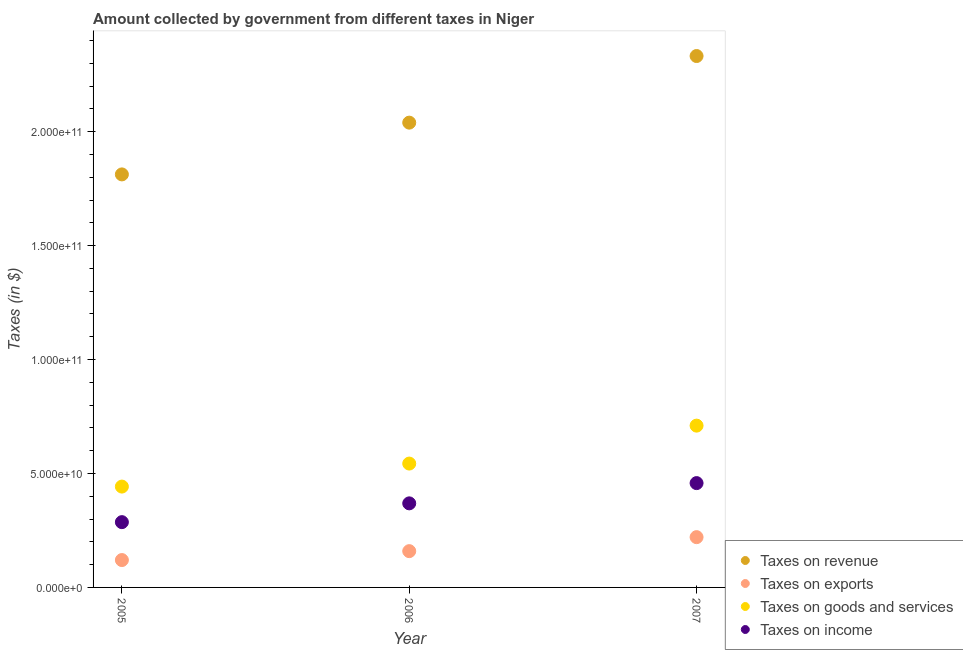How many different coloured dotlines are there?
Provide a short and direct response. 4. What is the amount collected as tax on revenue in 2007?
Provide a short and direct response. 2.33e+11. Across all years, what is the maximum amount collected as tax on exports?
Provide a succinct answer. 2.21e+1. Across all years, what is the minimum amount collected as tax on exports?
Your response must be concise. 1.20e+1. In which year was the amount collected as tax on goods maximum?
Give a very brief answer. 2007. In which year was the amount collected as tax on income minimum?
Provide a succinct answer. 2005. What is the total amount collected as tax on revenue in the graph?
Your answer should be compact. 6.18e+11. What is the difference between the amount collected as tax on exports in 2005 and that in 2006?
Your answer should be compact. -3.91e+09. What is the difference between the amount collected as tax on revenue in 2006 and the amount collected as tax on goods in 2005?
Offer a terse response. 1.60e+11. What is the average amount collected as tax on goods per year?
Ensure brevity in your answer.  5.65e+1. In the year 2005, what is the difference between the amount collected as tax on income and amount collected as tax on exports?
Offer a very short reply. 1.66e+1. In how many years, is the amount collected as tax on income greater than 90000000000 $?
Keep it short and to the point. 0. What is the ratio of the amount collected as tax on goods in 2005 to that in 2006?
Offer a very short reply. 0.81. Is the amount collected as tax on revenue in 2006 less than that in 2007?
Offer a terse response. Yes. What is the difference between the highest and the second highest amount collected as tax on goods?
Your answer should be very brief. 1.66e+1. What is the difference between the highest and the lowest amount collected as tax on revenue?
Make the answer very short. 5.19e+1. Is the sum of the amount collected as tax on income in 2005 and 2006 greater than the maximum amount collected as tax on revenue across all years?
Ensure brevity in your answer.  No. Is it the case that in every year, the sum of the amount collected as tax on exports and amount collected as tax on goods is greater than the sum of amount collected as tax on income and amount collected as tax on revenue?
Offer a very short reply. No. Is the amount collected as tax on revenue strictly less than the amount collected as tax on goods over the years?
Give a very brief answer. No. How many years are there in the graph?
Provide a succinct answer. 3. What is the difference between two consecutive major ticks on the Y-axis?
Offer a very short reply. 5.00e+1. Are the values on the major ticks of Y-axis written in scientific E-notation?
Ensure brevity in your answer.  Yes. How many legend labels are there?
Ensure brevity in your answer.  4. How are the legend labels stacked?
Give a very brief answer. Vertical. What is the title of the graph?
Offer a very short reply. Amount collected by government from different taxes in Niger. Does "Pre-primary schools" appear as one of the legend labels in the graph?
Your answer should be compact. No. What is the label or title of the X-axis?
Keep it short and to the point. Year. What is the label or title of the Y-axis?
Keep it short and to the point. Taxes (in $). What is the Taxes (in $) in Taxes on revenue in 2005?
Offer a terse response. 1.81e+11. What is the Taxes (in $) in Taxes on exports in 2005?
Keep it short and to the point. 1.20e+1. What is the Taxes (in $) in Taxes on goods and services in 2005?
Keep it short and to the point. 4.43e+1. What is the Taxes (in $) of Taxes on income in 2005?
Provide a succinct answer. 2.86e+1. What is the Taxes (in $) in Taxes on revenue in 2006?
Give a very brief answer. 2.04e+11. What is the Taxes (in $) of Taxes on exports in 2006?
Keep it short and to the point. 1.59e+1. What is the Taxes (in $) in Taxes on goods and services in 2006?
Provide a short and direct response. 5.43e+1. What is the Taxes (in $) in Taxes on income in 2006?
Offer a very short reply. 3.69e+1. What is the Taxes (in $) in Taxes on revenue in 2007?
Offer a terse response. 2.33e+11. What is the Taxes (in $) in Taxes on exports in 2007?
Provide a succinct answer. 2.21e+1. What is the Taxes (in $) of Taxes on goods and services in 2007?
Your answer should be compact. 7.10e+1. What is the Taxes (in $) in Taxes on income in 2007?
Your response must be concise. 4.58e+1. Across all years, what is the maximum Taxes (in $) of Taxes on revenue?
Keep it short and to the point. 2.33e+11. Across all years, what is the maximum Taxes (in $) in Taxes on exports?
Offer a terse response. 2.21e+1. Across all years, what is the maximum Taxes (in $) of Taxes on goods and services?
Offer a terse response. 7.10e+1. Across all years, what is the maximum Taxes (in $) of Taxes on income?
Your answer should be very brief. 4.58e+1. Across all years, what is the minimum Taxes (in $) in Taxes on revenue?
Provide a succinct answer. 1.81e+11. Across all years, what is the minimum Taxes (in $) in Taxes on exports?
Provide a succinct answer. 1.20e+1. Across all years, what is the minimum Taxes (in $) in Taxes on goods and services?
Offer a terse response. 4.43e+1. Across all years, what is the minimum Taxes (in $) of Taxes on income?
Provide a succinct answer. 2.86e+1. What is the total Taxes (in $) of Taxes on revenue in the graph?
Keep it short and to the point. 6.18e+11. What is the total Taxes (in $) in Taxes on exports in the graph?
Your answer should be compact. 5.00e+1. What is the total Taxes (in $) of Taxes on goods and services in the graph?
Your answer should be very brief. 1.70e+11. What is the total Taxes (in $) in Taxes on income in the graph?
Provide a succinct answer. 1.11e+11. What is the difference between the Taxes (in $) of Taxes on revenue in 2005 and that in 2006?
Provide a short and direct response. -2.27e+1. What is the difference between the Taxes (in $) in Taxes on exports in 2005 and that in 2006?
Ensure brevity in your answer.  -3.91e+09. What is the difference between the Taxes (in $) of Taxes on goods and services in 2005 and that in 2006?
Make the answer very short. -1.01e+1. What is the difference between the Taxes (in $) in Taxes on income in 2005 and that in 2006?
Offer a very short reply. -8.25e+09. What is the difference between the Taxes (in $) in Taxes on revenue in 2005 and that in 2007?
Ensure brevity in your answer.  -5.19e+1. What is the difference between the Taxes (in $) in Taxes on exports in 2005 and that in 2007?
Provide a short and direct response. -1.01e+1. What is the difference between the Taxes (in $) of Taxes on goods and services in 2005 and that in 2007?
Keep it short and to the point. -2.67e+1. What is the difference between the Taxes (in $) in Taxes on income in 2005 and that in 2007?
Ensure brevity in your answer.  -1.71e+1. What is the difference between the Taxes (in $) in Taxes on revenue in 2006 and that in 2007?
Give a very brief answer. -2.92e+1. What is the difference between the Taxes (in $) in Taxes on exports in 2006 and that in 2007?
Ensure brevity in your answer.  -6.14e+09. What is the difference between the Taxes (in $) of Taxes on goods and services in 2006 and that in 2007?
Give a very brief answer. -1.66e+1. What is the difference between the Taxes (in $) of Taxes on income in 2006 and that in 2007?
Make the answer very short. -8.88e+09. What is the difference between the Taxes (in $) in Taxes on revenue in 2005 and the Taxes (in $) in Taxes on exports in 2006?
Give a very brief answer. 1.65e+11. What is the difference between the Taxes (in $) of Taxes on revenue in 2005 and the Taxes (in $) of Taxes on goods and services in 2006?
Offer a very short reply. 1.27e+11. What is the difference between the Taxes (in $) in Taxes on revenue in 2005 and the Taxes (in $) in Taxes on income in 2006?
Keep it short and to the point. 1.44e+11. What is the difference between the Taxes (in $) in Taxes on exports in 2005 and the Taxes (in $) in Taxes on goods and services in 2006?
Your answer should be compact. -4.23e+1. What is the difference between the Taxes (in $) in Taxes on exports in 2005 and the Taxes (in $) in Taxes on income in 2006?
Offer a terse response. -2.49e+1. What is the difference between the Taxes (in $) in Taxes on goods and services in 2005 and the Taxes (in $) in Taxes on income in 2006?
Offer a terse response. 7.36e+09. What is the difference between the Taxes (in $) of Taxes on revenue in 2005 and the Taxes (in $) of Taxes on exports in 2007?
Offer a terse response. 1.59e+11. What is the difference between the Taxes (in $) of Taxes on revenue in 2005 and the Taxes (in $) of Taxes on goods and services in 2007?
Provide a short and direct response. 1.10e+11. What is the difference between the Taxes (in $) of Taxes on revenue in 2005 and the Taxes (in $) of Taxes on income in 2007?
Ensure brevity in your answer.  1.35e+11. What is the difference between the Taxes (in $) in Taxes on exports in 2005 and the Taxes (in $) in Taxes on goods and services in 2007?
Offer a very short reply. -5.90e+1. What is the difference between the Taxes (in $) of Taxes on exports in 2005 and the Taxes (in $) of Taxes on income in 2007?
Offer a very short reply. -3.38e+1. What is the difference between the Taxes (in $) in Taxes on goods and services in 2005 and the Taxes (in $) in Taxes on income in 2007?
Your response must be concise. -1.53e+09. What is the difference between the Taxes (in $) of Taxes on revenue in 2006 and the Taxes (in $) of Taxes on exports in 2007?
Your response must be concise. 1.82e+11. What is the difference between the Taxes (in $) of Taxes on revenue in 2006 and the Taxes (in $) of Taxes on goods and services in 2007?
Provide a short and direct response. 1.33e+11. What is the difference between the Taxes (in $) of Taxes on revenue in 2006 and the Taxes (in $) of Taxes on income in 2007?
Your answer should be compact. 1.58e+11. What is the difference between the Taxes (in $) in Taxes on exports in 2006 and the Taxes (in $) in Taxes on goods and services in 2007?
Your answer should be compact. -5.51e+1. What is the difference between the Taxes (in $) of Taxes on exports in 2006 and the Taxes (in $) of Taxes on income in 2007?
Offer a terse response. -2.99e+1. What is the difference between the Taxes (in $) of Taxes on goods and services in 2006 and the Taxes (in $) of Taxes on income in 2007?
Make the answer very short. 8.57e+09. What is the average Taxes (in $) in Taxes on revenue per year?
Provide a short and direct response. 2.06e+11. What is the average Taxes (in $) of Taxes on exports per year?
Your answer should be very brief. 1.67e+1. What is the average Taxes (in $) in Taxes on goods and services per year?
Provide a succinct answer. 5.65e+1. What is the average Taxes (in $) of Taxes on income per year?
Make the answer very short. 3.71e+1. In the year 2005, what is the difference between the Taxes (in $) in Taxes on revenue and Taxes (in $) in Taxes on exports?
Provide a short and direct response. 1.69e+11. In the year 2005, what is the difference between the Taxes (in $) in Taxes on revenue and Taxes (in $) in Taxes on goods and services?
Your answer should be very brief. 1.37e+11. In the year 2005, what is the difference between the Taxes (in $) in Taxes on revenue and Taxes (in $) in Taxes on income?
Your answer should be compact. 1.53e+11. In the year 2005, what is the difference between the Taxes (in $) of Taxes on exports and Taxes (in $) of Taxes on goods and services?
Ensure brevity in your answer.  -3.22e+1. In the year 2005, what is the difference between the Taxes (in $) of Taxes on exports and Taxes (in $) of Taxes on income?
Keep it short and to the point. -1.66e+1. In the year 2005, what is the difference between the Taxes (in $) in Taxes on goods and services and Taxes (in $) in Taxes on income?
Make the answer very short. 1.56e+1. In the year 2006, what is the difference between the Taxes (in $) in Taxes on revenue and Taxes (in $) in Taxes on exports?
Offer a very short reply. 1.88e+11. In the year 2006, what is the difference between the Taxes (in $) of Taxes on revenue and Taxes (in $) of Taxes on goods and services?
Offer a terse response. 1.50e+11. In the year 2006, what is the difference between the Taxes (in $) in Taxes on revenue and Taxes (in $) in Taxes on income?
Your answer should be very brief. 1.67e+11. In the year 2006, what is the difference between the Taxes (in $) in Taxes on exports and Taxes (in $) in Taxes on goods and services?
Give a very brief answer. -3.84e+1. In the year 2006, what is the difference between the Taxes (in $) of Taxes on exports and Taxes (in $) of Taxes on income?
Provide a succinct answer. -2.10e+1. In the year 2006, what is the difference between the Taxes (in $) in Taxes on goods and services and Taxes (in $) in Taxes on income?
Ensure brevity in your answer.  1.75e+1. In the year 2007, what is the difference between the Taxes (in $) in Taxes on revenue and Taxes (in $) in Taxes on exports?
Your response must be concise. 2.11e+11. In the year 2007, what is the difference between the Taxes (in $) of Taxes on revenue and Taxes (in $) of Taxes on goods and services?
Your answer should be compact. 1.62e+11. In the year 2007, what is the difference between the Taxes (in $) of Taxes on revenue and Taxes (in $) of Taxes on income?
Give a very brief answer. 1.87e+11. In the year 2007, what is the difference between the Taxes (in $) of Taxes on exports and Taxes (in $) of Taxes on goods and services?
Your answer should be very brief. -4.89e+1. In the year 2007, what is the difference between the Taxes (in $) in Taxes on exports and Taxes (in $) in Taxes on income?
Your answer should be compact. -2.37e+1. In the year 2007, what is the difference between the Taxes (in $) of Taxes on goods and services and Taxes (in $) of Taxes on income?
Provide a short and direct response. 2.52e+1. What is the ratio of the Taxes (in $) of Taxes on revenue in 2005 to that in 2006?
Make the answer very short. 0.89. What is the ratio of the Taxes (in $) of Taxes on exports in 2005 to that in 2006?
Your response must be concise. 0.75. What is the ratio of the Taxes (in $) of Taxes on goods and services in 2005 to that in 2006?
Your answer should be very brief. 0.81. What is the ratio of the Taxes (in $) in Taxes on income in 2005 to that in 2006?
Offer a very short reply. 0.78. What is the ratio of the Taxes (in $) of Taxes on revenue in 2005 to that in 2007?
Offer a very short reply. 0.78. What is the ratio of the Taxes (in $) in Taxes on exports in 2005 to that in 2007?
Your answer should be very brief. 0.54. What is the ratio of the Taxes (in $) of Taxes on goods and services in 2005 to that in 2007?
Offer a terse response. 0.62. What is the ratio of the Taxes (in $) of Taxes on income in 2005 to that in 2007?
Keep it short and to the point. 0.63. What is the ratio of the Taxes (in $) of Taxes on revenue in 2006 to that in 2007?
Provide a succinct answer. 0.87. What is the ratio of the Taxes (in $) of Taxes on exports in 2006 to that in 2007?
Make the answer very short. 0.72. What is the ratio of the Taxes (in $) in Taxes on goods and services in 2006 to that in 2007?
Your answer should be very brief. 0.77. What is the ratio of the Taxes (in $) in Taxes on income in 2006 to that in 2007?
Your answer should be compact. 0.81. What is the difference between the highest and the second highest Taxes (in $) in Taxes on revenue?
Your answer should be very brief. 2.92e+1. What is the difference between the highest and the second highest Taxes (in $) in Taxes on exports?
Give a very brief answer. 6.14e+09. What is the difference between the highest and the second highest Taxes (in $) in Taxes on goods and services?
Keep it short and to the point. 1.66e+1. What is the difference between the highest and the second highest Taxes (in $) of Taxes on income?
Ensure brevity in your answer.  8.88e+09. What is the difference between the highest and the lowest Taxes (in $) in Taxes on revenue?
Your response must be concise. 5.19e+1. What is the difference between the highest and the lowest Taxes (in $) in Taxes on exports?
Your response must be concise. 1.01e+1. What is the difference between the highest and the lowest Taxes (in $) of Taxes on goods and services?
Your answer should be very brief. 2.67e+1. What is the difference between the highest and the lowest Taxes (in $) in Taxes on income?
Keep it short and to the point. 1.71e+1. 